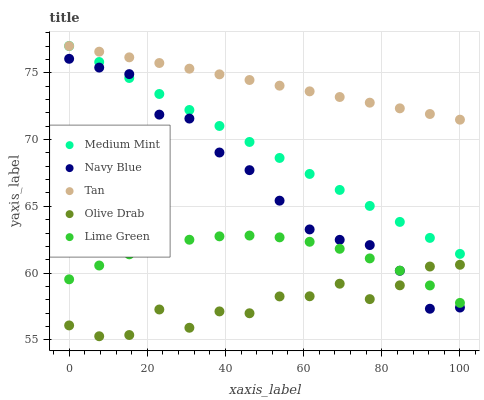Does Olive Drab have the minimum area under the curve?
Answer yes or no. Yes. Does Tan have the maximum area under the curve?
Answer yes or no. Yes. Does Navy Blue have the minimum area under the curve?
Answer yes or no. No. Does Navy Blue have the maximum area under the curve?
Answer yes or no. No. Is Medium Mint the smoothest?
Answer yes or no. Yes. Is Olive Drab the roughest?
Answer yes or no. Yes. Is Navy Blue the smoothest?
Answer yes or no. No. Is Navy Blue the roughest?
Answer yes or no. No. Does Olive Drab have the lowest value?
Answer yes or no. Yes. Does Navy Blue have the lowest value?
Answer yes or no. No. Does Tan have the highest value?
Answer yes or no. Yes. Does Navy Blue have the highest value?
Answer yes or no. No. Is Olive Drab less than Tan?
Answer yes or no. Yes. Is Tan greater than Navy Blue?
Answer yes or no. Yes. Does Olive Drab intersect Navy Blue?
Answer yes or no. Yes. Is Olive Drab less than Navy Blue?
Answer yes or no. No. Is Olive Drab greater than Navy Blue?
Answer yes or no. No. Does Olive Drab intersect Tan?
Answer yes or no. No. 